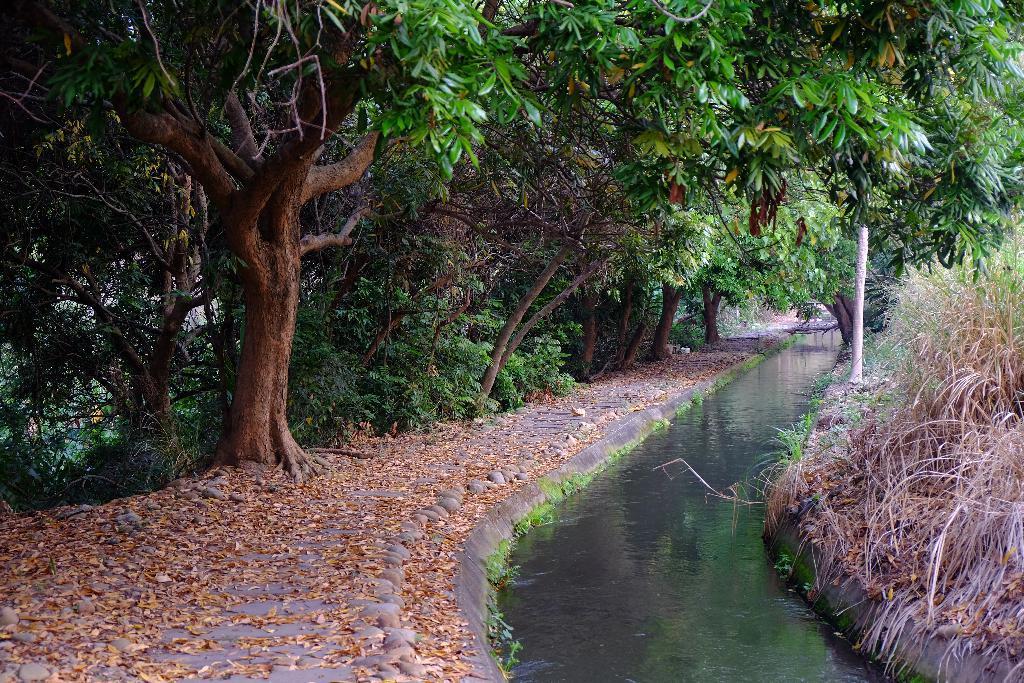Please provide a concise description of this image. There are water and there are trees in the left corner. 